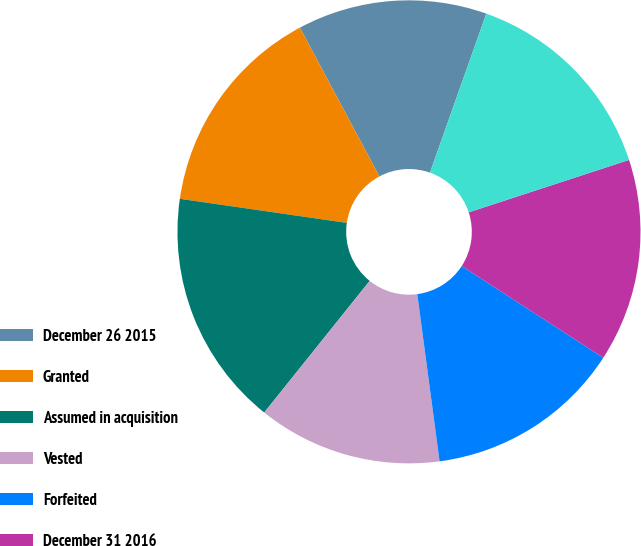Convert chart to OTSL. <chart><loc_0><loc_0><loc_500><loc_500><pie_chart><fcel>December 26 2015<fcel>Granted<fcel>Assumed in acquisition<fcel>Vested<fcel>Forfeited<fcel>December 31 2016<fcel>Expected to vest as of<nl><fcel>13.23%<fcel>14.91%<fcel>16.53%<fcel>12.86%<fcel>13.74%<fcel>14.18%<fcel>14.55%<nl></chart> 